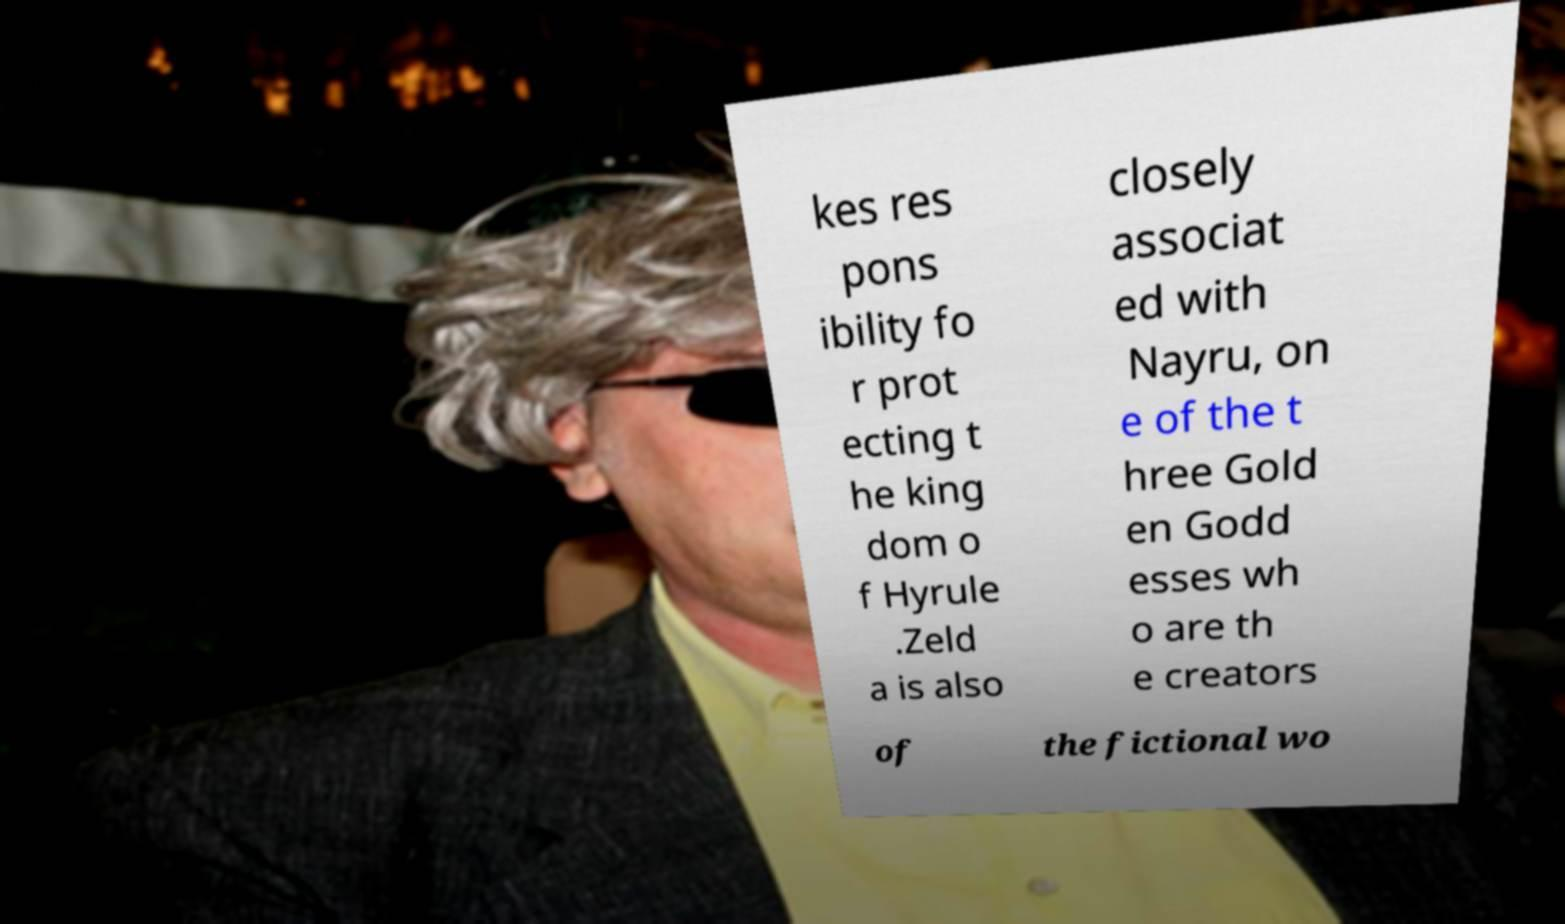Could you assist in decoding the text presented in this image and type it out clearly? kes res pons ibility fo r prot ecting t he king dom o f Hyrule .Zeld a is also closely associat ed with Nayru, on e of the t hree Gold en Godd esses wh o are th e creators of the fictional wo 